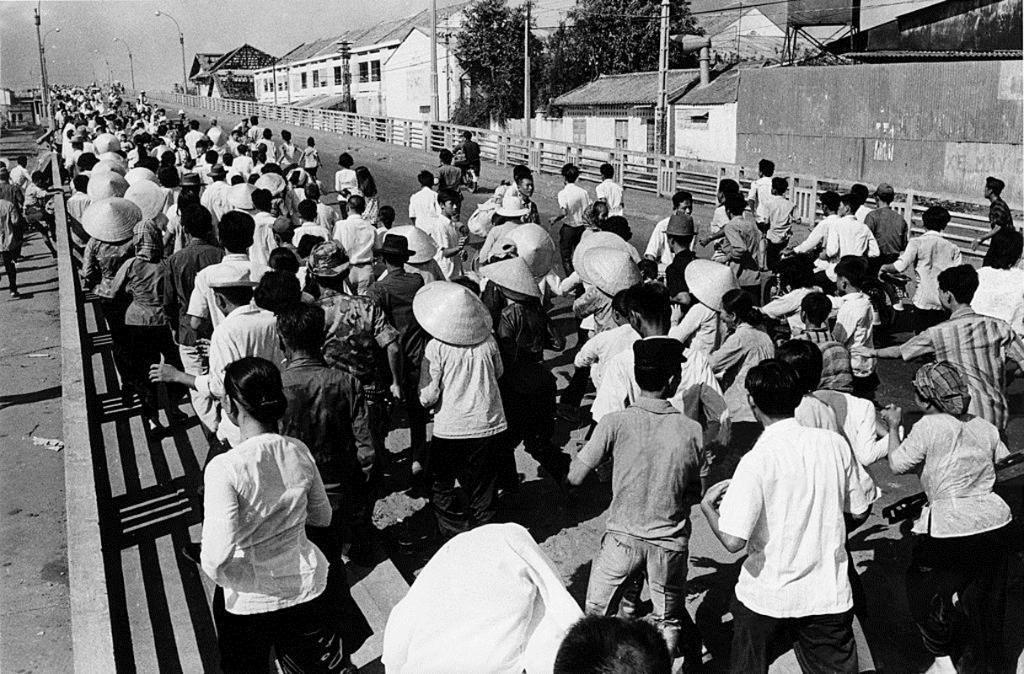What is the color scheme of the image? The image is black and white. What is happening on the road in the image? There is a crowd moving on the road. What can be seen on the right side of the road? There are houses on the right side of the road, and trees are between the houses. Can you see any popcorn being sold by a vendor in the image? There is no popcorn or vendor present in the image. Is there a giraffe visible among the crowd on the road? There is no giraffe present in the image; it features a crowd of people moving on the road. 